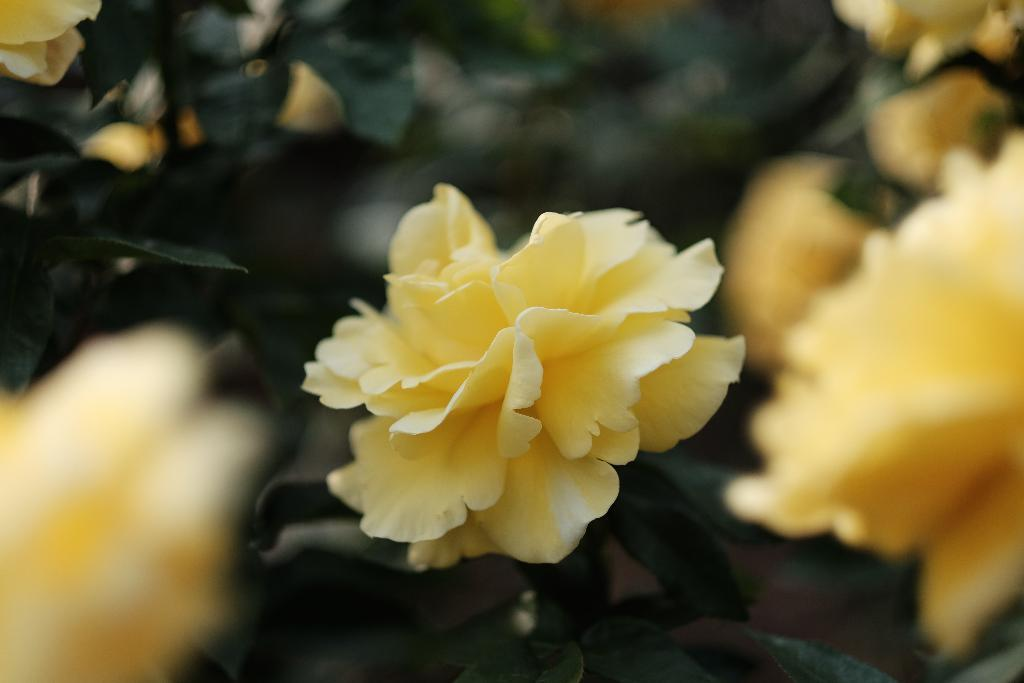What is the main subject of the image? There is a flower in the image. Can you describe the background of the image? The background of the image is blurred. Is there a river flowing through the flower in the image? No, there is no river present in the image. What type of tool is used to cut the flower in the image? There is no tool, such as scissors, depicted in the image. 